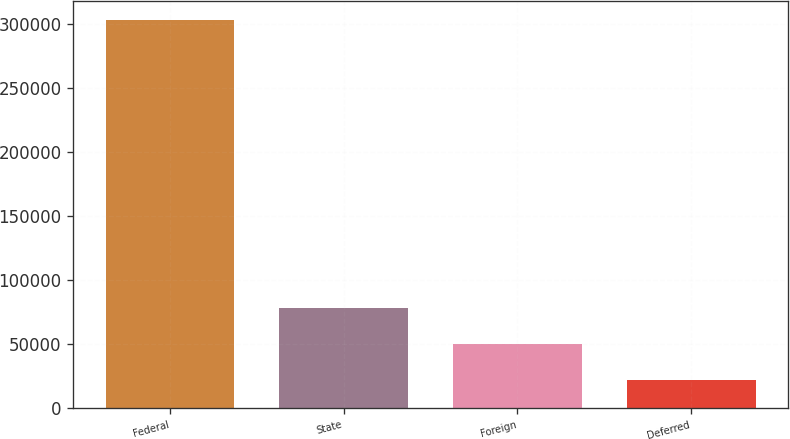Convert chart to OTSL. <chart><loc_0><loc_0><loc_500><loc_500><bar_chart><fcel>Federal<fcel>State<fcel>Foreign<fcel>Deferred<nl><fcel>303016<fcel>77900.8<fcel>49761.4<fcel>21622<nl></chart> 